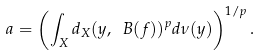Convert formula to latex. <formula><loc_0><loc_0><loc_500><loc_500>a = \left ( \int _ { X } d _ { X } ( y , \ B ( f ) ) ^ { p } d \nu ( y ) \right ) ^ { 1 / p } .</formula> 